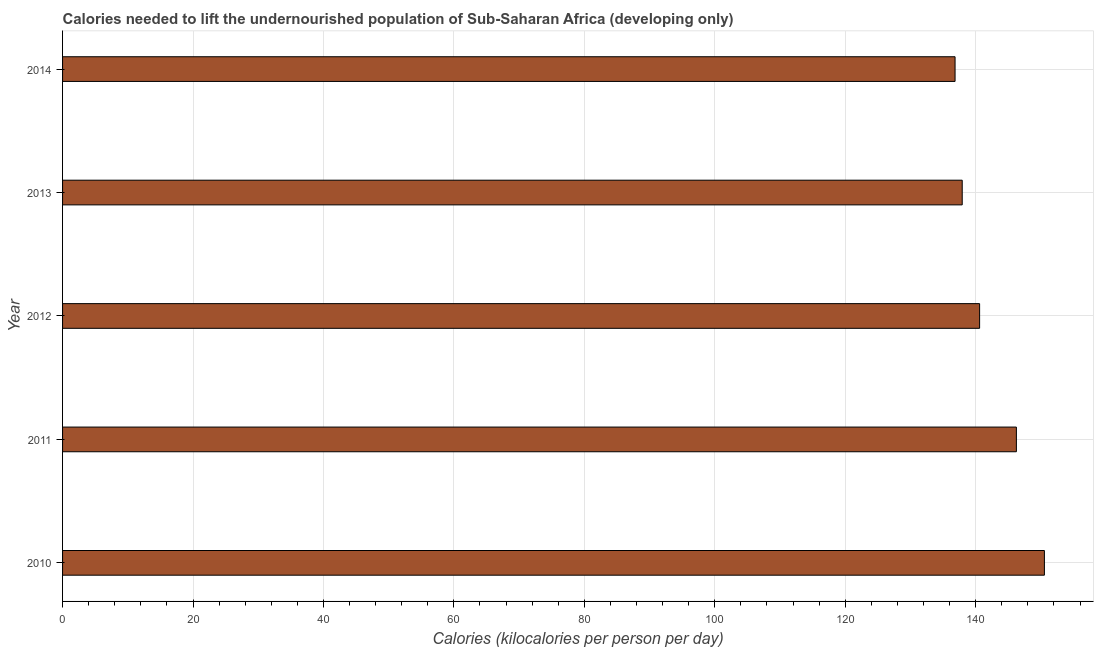Does the graph contain any zero values?
Provide a succinct answer. No. Does the graph contain grids?
Your response must be concise. Yes. What is the title of the graph?
Offer a terse response. Calories needed to lift the undernourished population of Sub-Saharan Africa (developing only). What is the label or title of the X-axis?
Offer a terse response. Calories (kilocalories per person per day). What is the depth of food deficit in 2011?
Your response must be concise. 146.24. Across all years, what is the maximum depth of food deficit?
Provide a succinct answer. 150.54. Across all years, what is the minimum depth of food deficit?
Offer a terse response. 136.84. In which year was the depth of food deficit maximum?
Ensure brevity in your answer.  2010. In which year was the depth of food deficit minimum?
Your answer should be very brief. 2014. What is the sum of the depth of food deficit?
Provide a succinct answer. 712.15. What is the difference between the depth of food deficit in 2012 and 2013?
Make the answer very short. 2.67. What is the average depth of food deficit per year?
Ensure brevity in your answer.  142.43. What is the median depth of food deficit?
Offer a very short reply. 140.6. In how many years, is the depth of food deficit greater than 140 kilocalories?
Keep it short and to the point. 3. Do a majority of the years between 2011 and 2010 (inclusive) have depth of food deficit greater than 148 kilocalories?
Your answer should be very brief. No. What is the ratio of the depth of food deficit in 2010 to that in 2013?
Offer a terse response. 1.09. Is the depth of food deficit in 2010 less than that in 2014?
Offer a terse response. No. Is the difference between the depth of food deficit in 2011 and 2012 greater than the difference between any two years?
Offer a terse response. No. What is the difference between the highest and the second highest depth of food deficit?
Ensure brevity in your answer.  4.29. Are all the bars in the graph horizontal?
Make the answer very short. Yes. What is the difference between two consecutive major ticks on the X-axis?
Your answer should be very brief. 20. What is the Calories (kilocalories per person per day) in 2010?
Offer a terse response. 150.54. What is the Calories (kilocalories per person per day) in 2011?
Provide a succinct answer. 146.24. What is the Calories (kilocalories per person per day) in 2012?
Provide a succinct answer. 140.6. What is the Calories (kilocalories per person per day) in 2013?
Provide a short and direct response. 137.94. What is the Calories (kilocalories per person per day) in 2014?
Ensure brevity in your answer.  136.84. What is the difference between the Calories (kilocalories per person per day) in 2010 and 2011?
Make the answer very short. 4.3. What is the difference between the Calories (kilocalories per person per day) in 2010 and 2012?
Offer a very short reply. 9.93. What is the difference between the Calories (kilocalories per person per day) in 2010 and 2013?
Your response must be concise. 12.6. What is the difference between the Calories (kilocalories per person per day) in 2010 and 2014?
Your answer should be very brief. 13.7. What is the difference between the Calories (kilocalories per person per day) in 2011 and 2012?
Keep it short and to the point. 5.64. What is the difference between the Calories (kilocalories per person per day) in 2011 and 2013?
Your response must be concise. 8.31. What is the difference between the Calories (kilocalories per person per day) in 2011 and 2014?
Provide a short and direct response. 9.4. What is the difference between the Calories (kilocalories per person per day) in 2012 and 2013?
Provide a short and direct response. 2.67. What is the difference between the Calories (kilocalories per person per day) in 2012 and 2014?
Offer a terse response. 3.76. What is the difference between the Calories (kilocalories per person per day) in 2013 and 2014?
Provide a succinct answer. 1.1. What is the ratio of the Calories (kilocalories per person per day) in 2010 to that in 2011?
Provide a short and direct response. 1.03. What is the ratio of the Calories (kilocalories per person per day) in 2010 to that in 2012?
Provide a succinct answer. 1.07. What is the ratio of the Calories (kilocalories per person per day) in 2010 to that in 2013?
Keep it short and to the point. 1.09. What is the ratio of the Calories (kilocalories per person per day) in 2010 to that in 2014?
Your answer should be compact. 1.1. What is the ratio of the Calories (kilocalories per person per day) in 2011 to that in 2013?
Ensure brevity in your answer.  1.06. What is the ratio of the Calories (kilocalories per person per day) in 2011 to that in 2014?
Your response must be concise. 1.07. What is the ratio of the Calories (kilocalories per person per day) in 2012 to that in 2013?
Give a very brief answer. 1.02. What is the ratio of the Calories (kilocalories per person per day) in 2012 to that in 2014?
Make the answer very short. 1.03. What is the ratio of the Calories (kilocalories per person per day) in 2013 to that in 2014?
Ensure brevity in your answer.  1.01. 